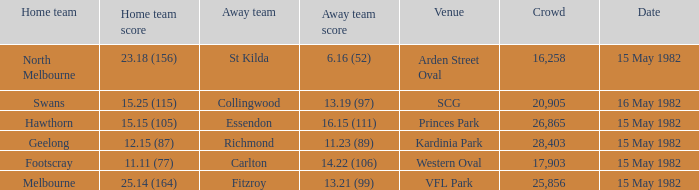Which home team played against the away team with a score of 13.19 (97)? Swans. 